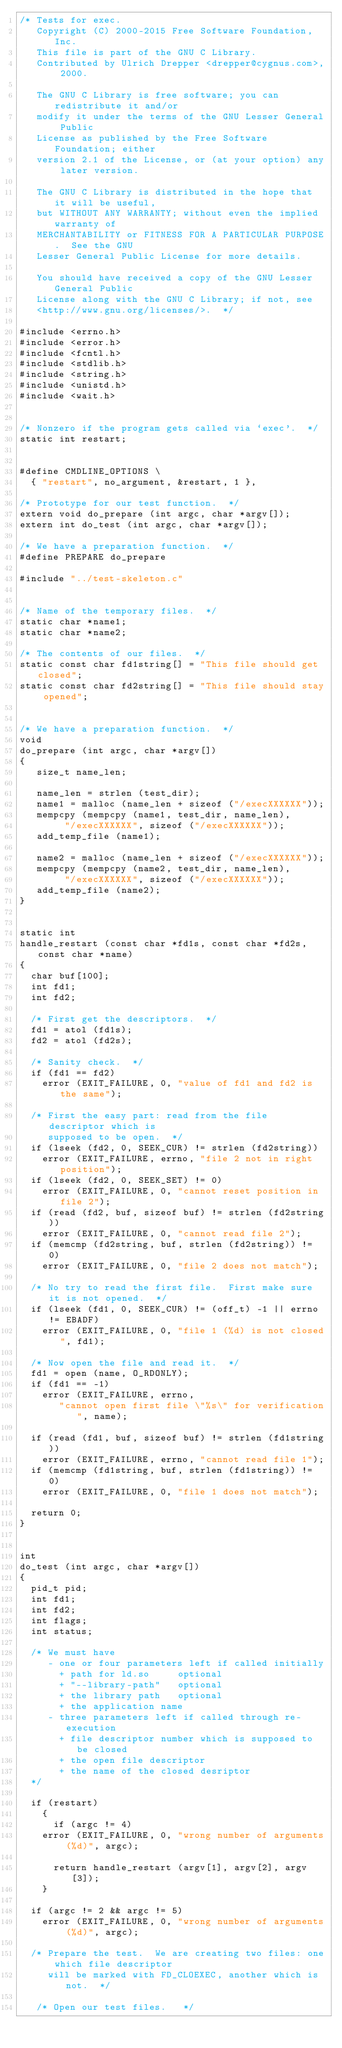<code> <loc_0><loc_0><loc_500><loc_500><_C_>/* Tests for exec.
   Copyright (C) 2000-2015 Free Software Foundation, Inc.
   This file is part of the GNU C Library.
   Contributed by Ulrich Drepper <drepper@cygnus.com>, 2000.

   The GNU C Library is free software; you can redistribute it and/or
   modify it under the terms of the GNU Lesser General Public
   License as published by the Free Software Foundation; either
   version 2.1 of the License, or (at your option) any later version.

   The GNU C Library is distributed in the hope that it will be useful,
   but WITHOUT ANY WARRANTY; without even the implied warranty of
   MERCHANTABILITY or FITNESS FOR A PARTICULAR PURPOSE.  See the GNU
   Lesser General Public License for more details.

   You should have received a copy of the GNU Lesser General Public
   License along with the GNU C Library; if not, see
   <http://www.gnu.org/licenses/>.  */

#include <errno.h>
#include <error.h>
#include <fcntl.h>
#include <stdlib.h>
#include <string.h>
#include <unistd.h>
#include <wait.h>


/* Nonzero if the program gets called via `exec'.  */
static int restart;


#define CMDLINE_OPTIONS \
  { "restart", no_argument, &restart, 1 },

/* Prototype for our test function.  */
extern void do_prepare (int argc, char *argv[]);
extern int do_test (int argc, char *argv[]);

/* We have a preparation function.  */
#define PREPARE do_prepare

#include "../test-skeleton.c"


/* Name of the temporary files.  */
static char *name1;
static char *name2;

/* The contents of our files.  */
static const char fd1string[] = "This file should get closed";
static const char fd2string[] = "This file should stay opened";


/* We have a preparation function.  */
void
do_prepare (int argc, char *argv[])
{
   size_t name_len;

   name_len = strlen (test_dir);
   name1 = malloc (name_len + sizeof ("/execXXXXXX"));
   mempcpy (mempcpy (name1, test_dir, name_len),
	    "/execXXXXXX", sizeof ("/execXXXXXX"));
   add_temp_file (name1);

   name2 = malloc (name_len + sizeof ("/execXXXXXX"));
   mempcpy (mempcpy (name2, test_dir, name_len),
	    "/execXXXXXX", sizeof ("/execXXXXXX"));
   add_temp_file (name2);
}


static int
handle_restart (const char *fd1s, const char *fd2s, const char *name)
{
  char buf[100];
  int fd1;
  int fd2;

  /* First get the descriptors.  */
  fd1 = atol (fd1s);
  fd2 = atol (fd2s);

  /* Sanity check.  */
  if (fd1 == fd2)
    error (EXIT_FAILURE, 0, "value of fd1 and fd2 is the same");

  /* First the easy part: read from the file descriptor which is
     supposed to be open.  */
  if (lseek (fd2, 0, SEEK_CUR) != strlen (fd2string))
    error (EXIT_FAILURE, errno, "file 2 not in right position");
  if (lseek (fd2, 0, SEEK_SET) != 0)
    error (EXIT_FAILURE, 0, "cannot reset position in file 2");
  if (read (fd2, buf, sizeof buf) != strlen (fd2string))
    error (EXIT_FAILURE, 0, "cannot read file 2");
  if (memcmp (fd2string, buf, strlen (fd2string)) != 0)
    error (EXIT_FAILURE, 0, "file 2 does not match");

  /* No try to read the first file.  First make sure it is not opened.  */
  if (lseek (fd1, 0, SEEK_CUR) != (off_t) -1 || errno != EBADF)
    error (EXIT_FAILURE, 0, "file 1 (%d) is not closed", fd1);

  /* Now open the file and read it.  */
  fd1 = open (name, O_RDONLY);
  if (fd1 == -1)
    error (EXIT_FAILURE, errno,
	   "cannot open first file \"%s\" for verification", name);

  if (read (fd1, buf, sizeof buf) != strlen (fd1string))
    error (EXIT_FAILURE, errno, "cannot read file 1");
  if (memcmp (fd1string, buf, strlen (fd1string)) != 0)
    error (EXIT_FAILURE, 0, "file 1 does not match");

  return 0;
}


int
do_test (int argc, char *argv[])
{
  pid_t pid;
  int fd1;
  int fd2;
  int flags;
  int status;

  /* We must have
     - one or four parameters left if called initially
       + path for ld.so		optional
       + "--library-path"	optional
       + the library path	optional
       + the application name
     - three parameters left if called through re-execution
       + file descriptor number which is supposed to be closed
       + the open file descriptor
       + the name of the closed desriptor
  */

  if (restart)
    {
      if (argc != 4)
	error (EXIT_FAILURE, 0, "wrong number of arguments (%d)", argc);

      return handle_restart (argv[1], argv[2], argv[3]);
    }

  if (argc != 2 && argc != 5)
    error (EXIT_FAILURE, 0, "wrong number of arguments (%d)", argc);

  /* Prepare the test.  We are creating two files: one which file descriptor
     will be marked with FD_CLOEXEC, another which is not.  */

   /* Open our test files.   */</code> 